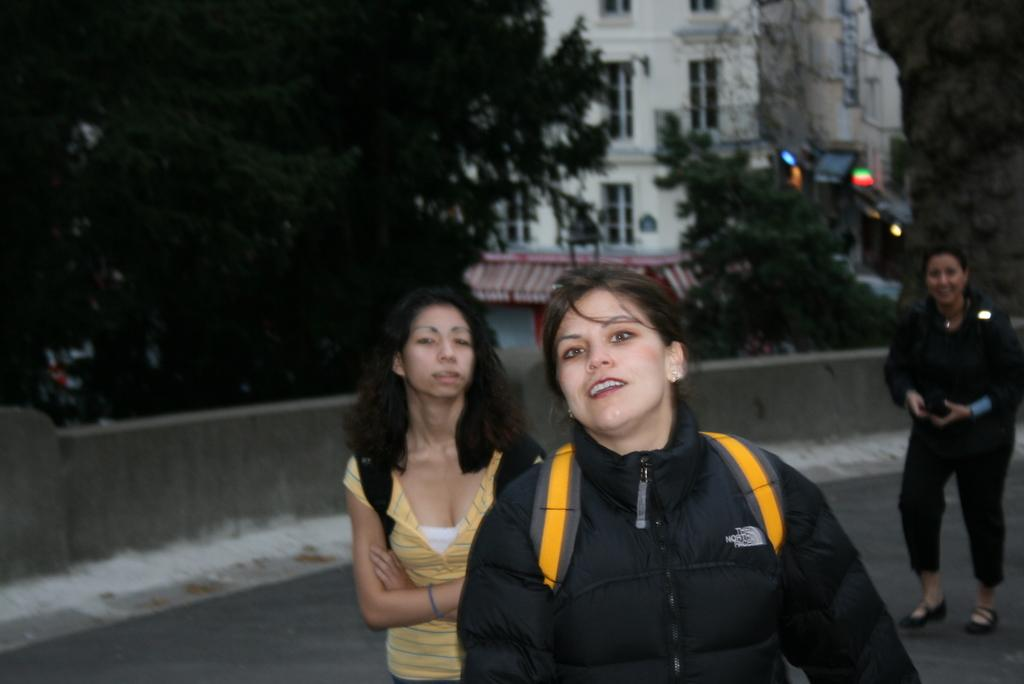Who or what is present in the image? There are people in the image. What can be seen in the foreground of the image? There is a wall visible in the image. What type of natural elements are present in the image? There are trees in the image. What can be seen in the background of the image? There is a building and lights in the background of the image. What type of whip can be seen being used by the people in the image? There is no whip present in the image; the people are not using any whips. 